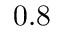Convert formula to latex. <formula><loc_0><loc_0><loc_500><loc_500>0 . 8</formula> 